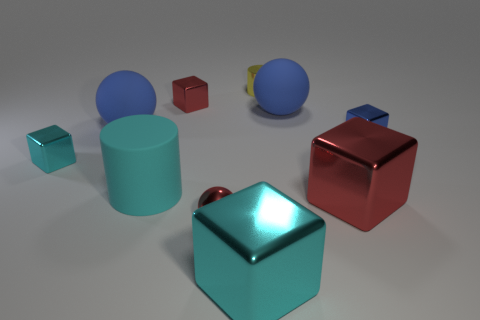Subtract 2 blocks. How many blocks are left? 3 Subtract all small red cubes. How many cubes are left? 4 Subtract all blue cubes. How many cubes are left? 4 Subtract all yellow cubes. Subtract all cyan cylinders. How many cubes are left? 5 Subtract all spheres. How many objects are left? 7 Add 1 tiny cyan metallic objects. How many tiny cyan metallic objects exist? 2 Subtract 0 yellow cubes. How many objects are left? 10 Subtract all big rubber objects. Subtract all big cyan metal things. How many objects are left? 6 Add 4 small red cubes. How many small red cubes are left? 5 